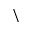Convert formula to latex. <formula><loc_0><loc_0><loc_500><loc_500>\</formula> 